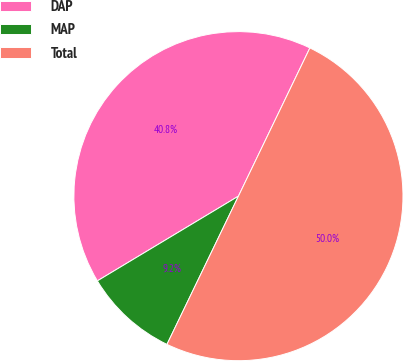Convert chart. <chart><loc_0><loc_0><loc_500><loc_500><pie_chart><fcel>DAP<fcel>MAP<fcel>Total<nl><fcel>40.76%<fcel>9.24%<fcel>50.0%<nl></chart> 